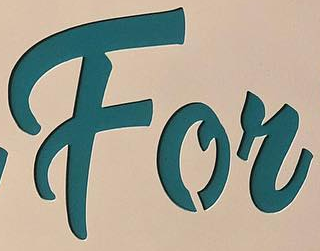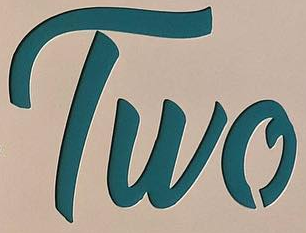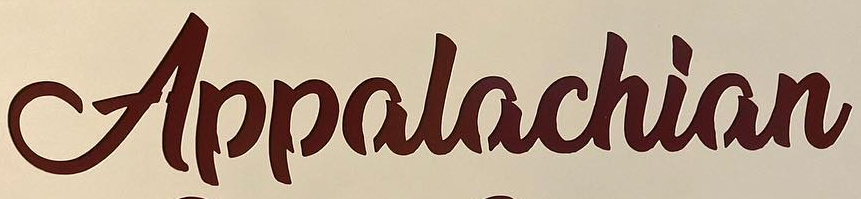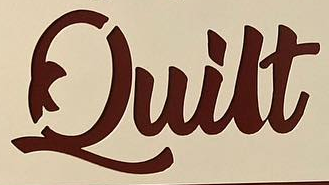Read the text content from these images in order, separated by a semicolon. For; Two; Appalachian; Quilt 